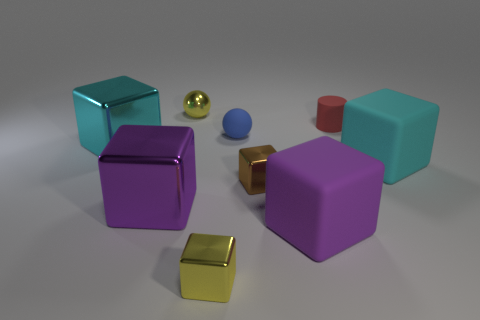Are there more big purple objects than purple rubber objects?
Provide a succinct answer. Yes. What number of other things are there of the same material as the tiny yellow block
Offer a terse response. 4. How many objects are either tiny red things or large objects left of the brown metallic object?
Give a very brief answer. 3. Are there fewer yellow spheres than small shiny blocks?
Provide a succinct answer. Yes. The ball to the right of the yellow object in front of the cyan cube to the left of the large cyan rubber cube is what color?
Provide a succinct answer. Blue. Are the blue object and the red cylinder made of the same material?
Provide a succinct answer. Yes. What number of tiny rubber things are on the right side of the small blue thing?
Your answer should be very brief. 1. There is a yellow object that is the same shape as the small brown shiny thing; what size is it?
Your answer should be compact. Small. How many gray things are rubber objects or tiny matte cylinders?
Your answer should be compact. 0. There is a large cyan thing that is behind the big cyan rubber object; how many tiny brown metallic things are to the left of it?
Offer a terse response. 0. 